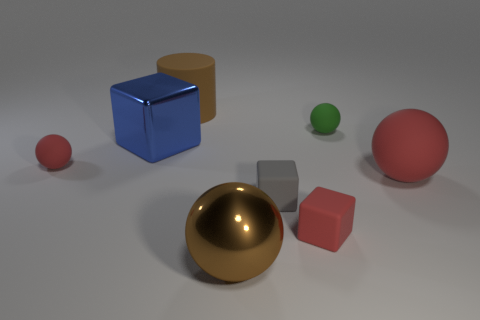Are there any other rubber objects that have the same size as the green object?
Your answer should be very brief. Yes. Is the number of green balls in front of the brown sphere less than the number of blue metal things?
Ensure brevity in your answer.  Yes. What material is the tiny red thing behind the small red rubber block that is in front of the red object that is left of the red cube?
Make the answer very short. Rubber. Are there more big shiny balls in front of the small red sphere than blue objects that are behind the big blue object?
Keep it short and to the point. Yes. How many metal things are either purple cylinders or green spheres?
Provide a succinct answer. 0. The large thing that is the same color as the matte cylinder is what shape?
Your answer should be compact. Sphere. There is a red object that is behind the big red rubber ball; what is it made of?
Provide a succinct answer. Rubber. How many things are large things or green things that are behind the small gray matte object?
Your answer should be compact. 5. What shape is the green object that is the same size as the gray rubber thing?
Provide a succinct answer. Sphere. How many large cylinders have the same color as the shiny cube?
Your answer should be compact. 0. 